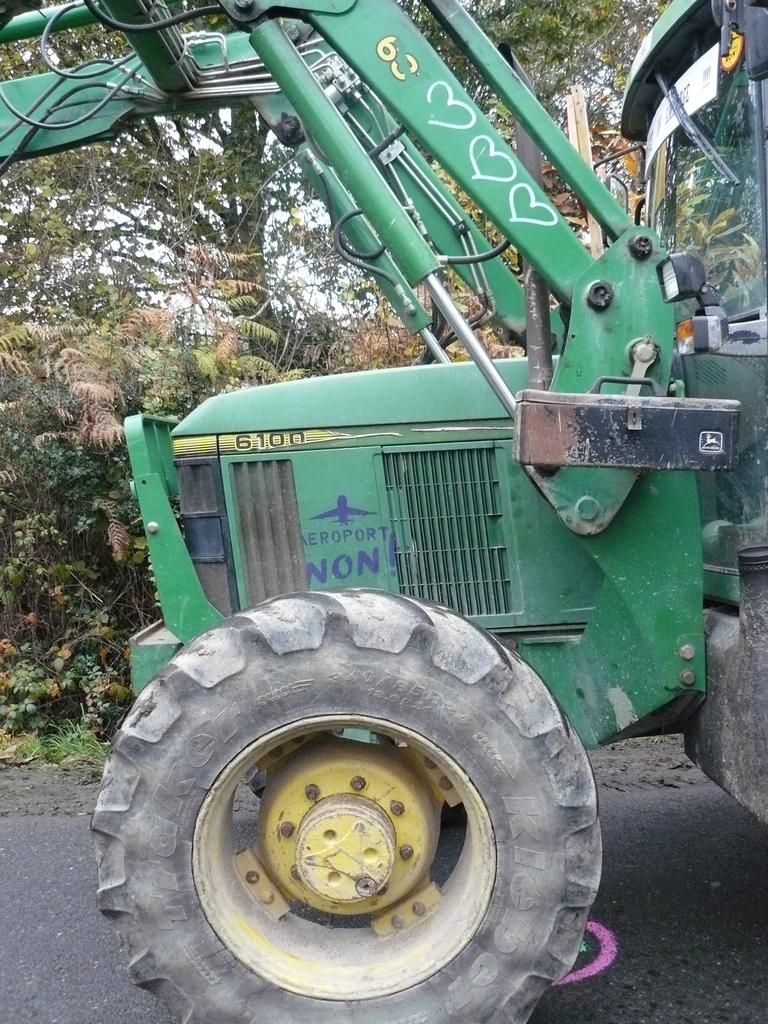What is on the road in the image? There is a vehicle on the road in the image. What can be seen in the distance in the image? There are trees in the background of the image. Where is the glass located in the image? The glass is on the left side of the image. What grade does the vehicle receive for its performance in the image? There is no grade assigned to the vehicle's performance in the image, as it is not a test or evaluation scenario. 